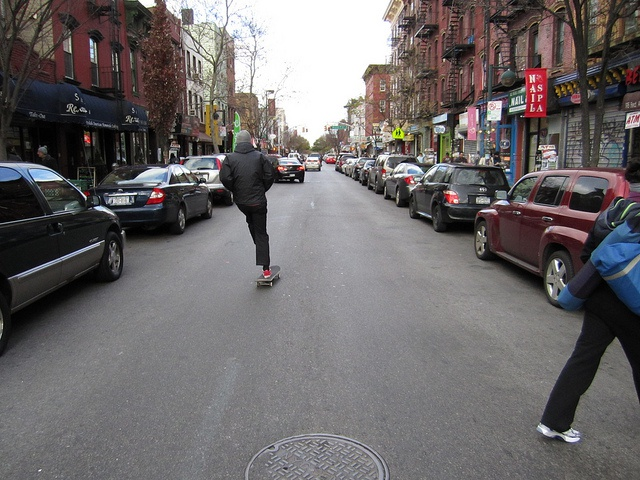Describe the objects in this image and their specific colors. I can see car in gray, black, and darkgray tones, people in gray, black, navy, and blue tones, car in gray, black, maroon, and darkgray tones, car in gray, black, lightgray, and darkgray tones, and car in gray, black, darkgray, and lightgray tones in this image. 